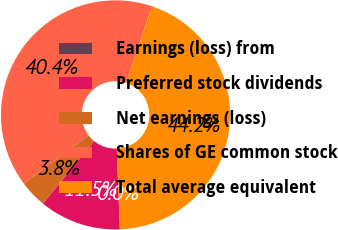<chart> <loc_0><loc_0><loc_500><loc_500><pie_chart><fcel>Earnings (loss) from<fcel>Preferred stock dividends<fcel>Net earnings (loss)<fcel>Shares of GE common stock<fcel>Total average equivalent<nl><fcel>0.0%<fcel>11.52%<fcel>3.84%<fcel>40.4%<fcel>44.24%<nl></chart> 